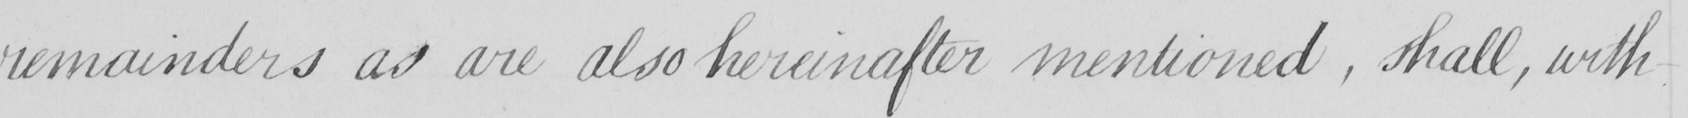Please transcribe the handwritten text in this image. remainders as are also hereinafter mentioned  , shall , with 